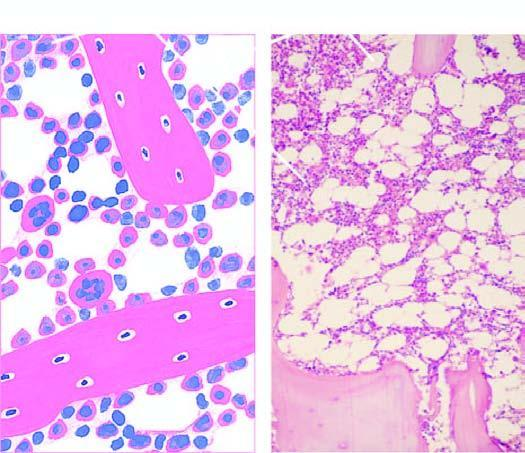what consists of haematopoietic tissue?
Answer the question using a single word or phrase. Approximately 50% of the soft tissue of the bone 